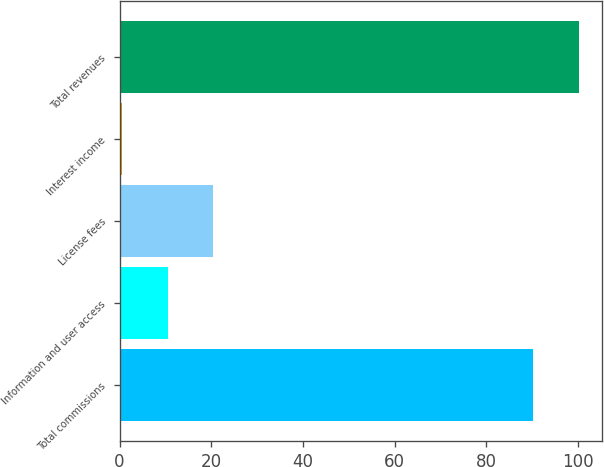<chart> <loc_0><loc_0><loc_500><loc_500><bar_chart><fcel>Total commissions<fcel>Information and user access<fcel>License fees<fcel>Interest income<fcel>Total revenues<nl><fcel>90.3<fcel>10.54<fcel>20.48<fcel>0.6<fcel>100.24<nl></chart> 